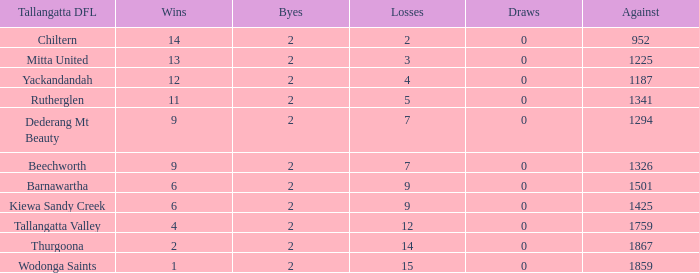How many draws are there if there are less than 9 wins and less than 2 byes? 0.0. 